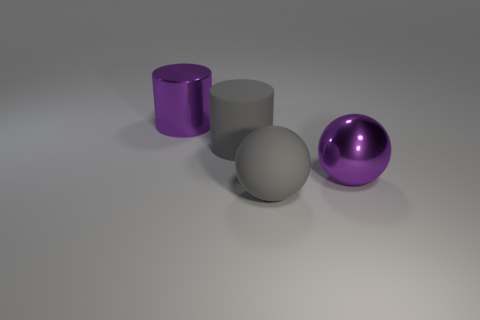Subtract all red balls. Subtract all blue cubes. How many balls are left? 2 Add 4 big purple spheres. How many objects exist? 8 Subtract 0 green cubes. How many objects are left? 4 Subtract all large purple metallic cylinders. Subtract all purple metal cylinders. How many objects are left? 2 Add 4 large rubber cylinders. How many large rubber cylinders are left? 5 Add 2 tiny purple balls. How many tiny purple balls exist? 2 